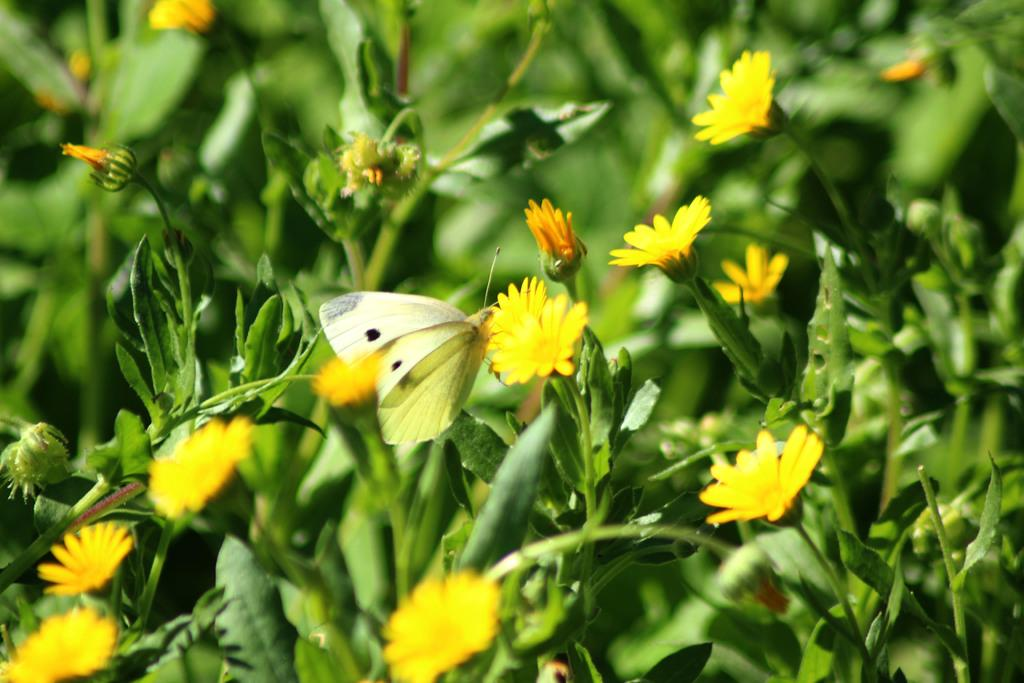What is the main subject of the image? The main subject of the image is a butterfly on a flower. What is the butterfly doing in the image? The butterfly is perched on a flower. What else can be seen in the image besides the butterfly and flower? There is a group of plants with flowers around the butterfly and flower. What color of paint is being used by the watch in the image? There is no watch or paint present in the image; it features a butterfly on a flower surrounded by plants with flowers. 